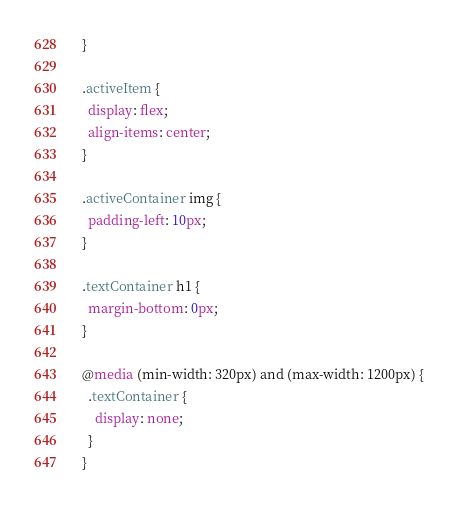Convert code to text. <code><loc_0><loc_0><loc_500><loc_500><_CSS_>  }
  
  .activeItem {
    display: flex;
    align-items: center;
  }
  
  .activeContainer img {
    padding-left: 10px;
  }
  
  .textContainer h1 {
    margin-bottom: 0px;
  }
  
  @media (min-width: 320px) and (max-width: 1200px) {
    .textContainer {
      display: none;
    }
  }</code> 